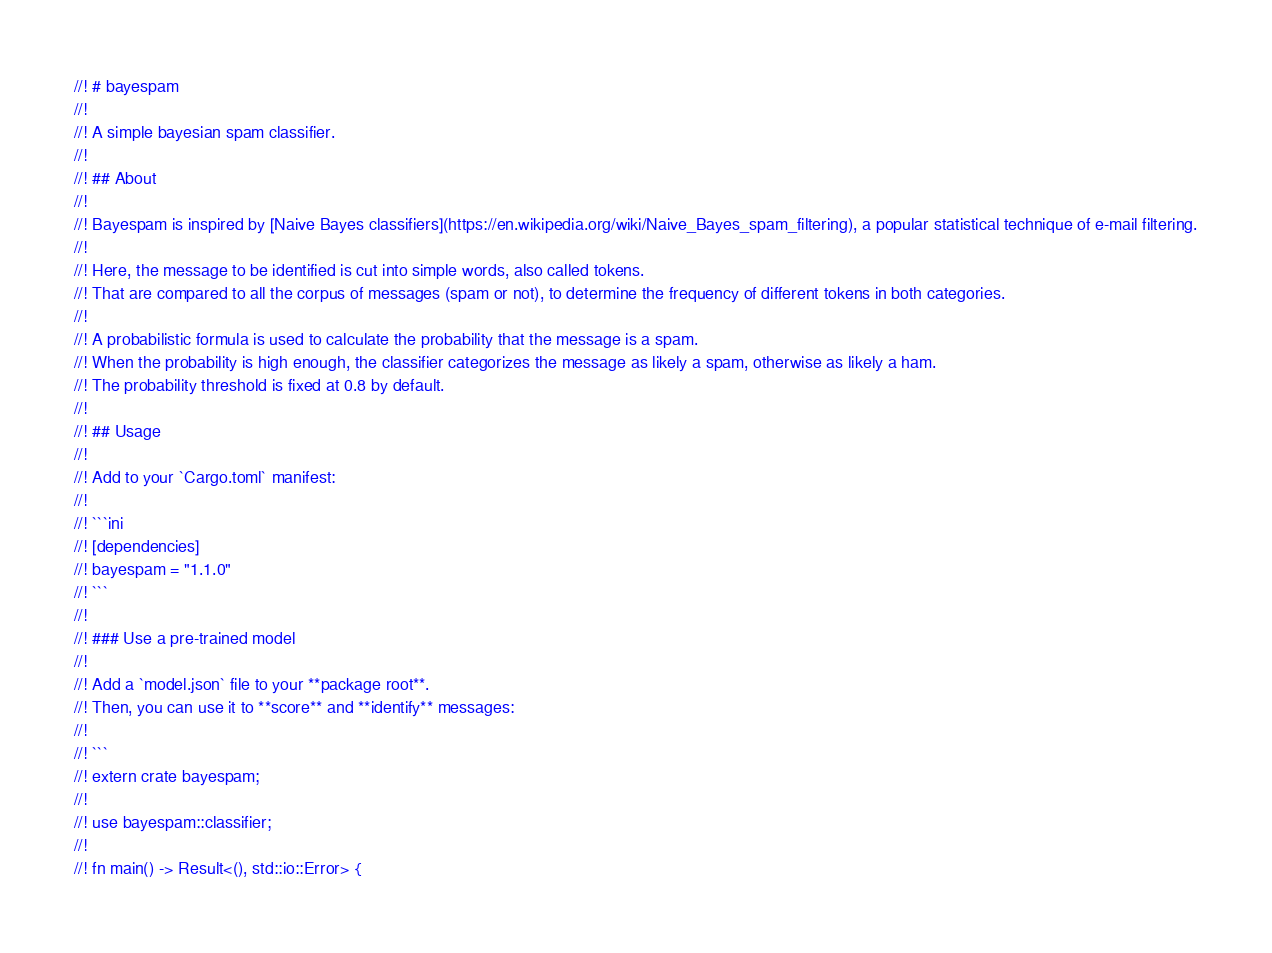<code> <loc_0><loc_0><loc_500><loc_500><_Rust_>//! # bayespam
//!
//! A simple bayesian spam classifier.
//!
//! ## About
//!
//! Bayespam is inspired by [Naive Bayes classifiers](https://en.wikipedia.org/wiki/Naive_Bayes_spam_filtering), a popular statistical technique of e-mail filtering.
//!
//! Here, the message to be identified is cut into simple words, also called tokens.
//! That are compared to all the corpus of messages (spam or not), to determine the frequency of different tokens in both categories.
//!
//! A probabilistic formula is used to calculate the probability that the message is a spam.
//! When the probability is high enough, the classifier categorizes the message as likely a spam, otherwise as likely a ham.
//! The probability threshold is fixed at 0.8 by default.
//!
//! ## Usage
//!
//! Add to your `Cargo.toml` manifest:
//!
//! ```ini
//! [dependencies]
//! bayespam = "1.1.0"
//! ```
//!
//! ### Use a pre-trained model
//!
//! Add a `model.json` file to your **package root**.
//! Then, you can use it to **score** and **identify** messages:
//!
//! ```
//! extern crate bayespam;
//!
//! use bayespam::classifier;
//!
//! fn main() -> Result<(), std::io::Error> {</code> 